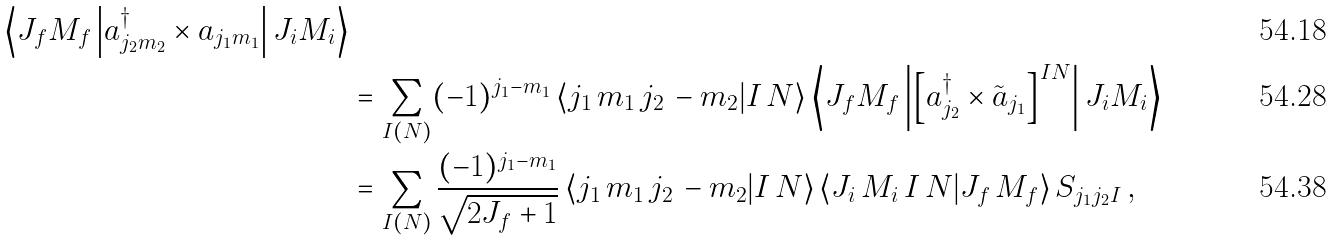Convert formula to latex. <formula><loc_0><loc_0><loc_500><loc_500>{ \left \langle J _ { f } M _ { f } \left | a ^ { \dagger } _ { j _ { 2 } m _ { 2 } } \times a _ { j _ { 1 } m _ { 1 } } \right | J _ { i } M _ { i } \right \rangle } \\ & = \sum _ { I ( N ) } ( - 1 ) ^ { j _ { 1 } - m _ { 1 } } \left \langle j _ { 1 } \, m _ { 1 } \, j _ { 2 } \, - m _ { 2 } | I \, N \right \rangle \left \langle J _ { f } M _ { f } \left | \left [ a ^ { \dagger } _ { j _ { 2 } } \times \tilde { a } _ { j _ { 1 } } \right ] ^ { I N } \right | J _ { i } M _ { i } \right \rangle \\ & = \sum _ { I ( N ) } \frac { ( - 1 ) ^ { j _ { 1 } - m _ { 1 } } } { \sqrt { 2 J _ { f } + 1 } } \left \langle j _ { 1 } \, m _ { 1 } \, j _ { 2 } \, - m _ { 2 } | I \, N \right \rangle \left \langle J _ { i } \, M _ { i } \, I \, N | J _ { f } \, M _ { f } \right \rangle S _ { j _ { 1 } j _ { 2 } I } \, ,</formula> 